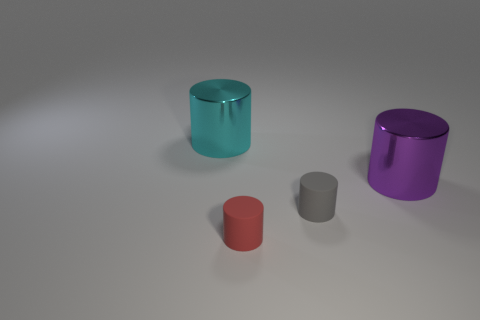Add 3 matte things. How many objects exist? 7 Add 4 purple things. How many purple things are left? 5 Add 2 tiny brown metal balls. How many tiny brown metal balls exist? 2 Subtract 0 green balls. How many objects are left? 4 Subtract all large red spheres. Subtract all rubber things. How many objects are left? 2 